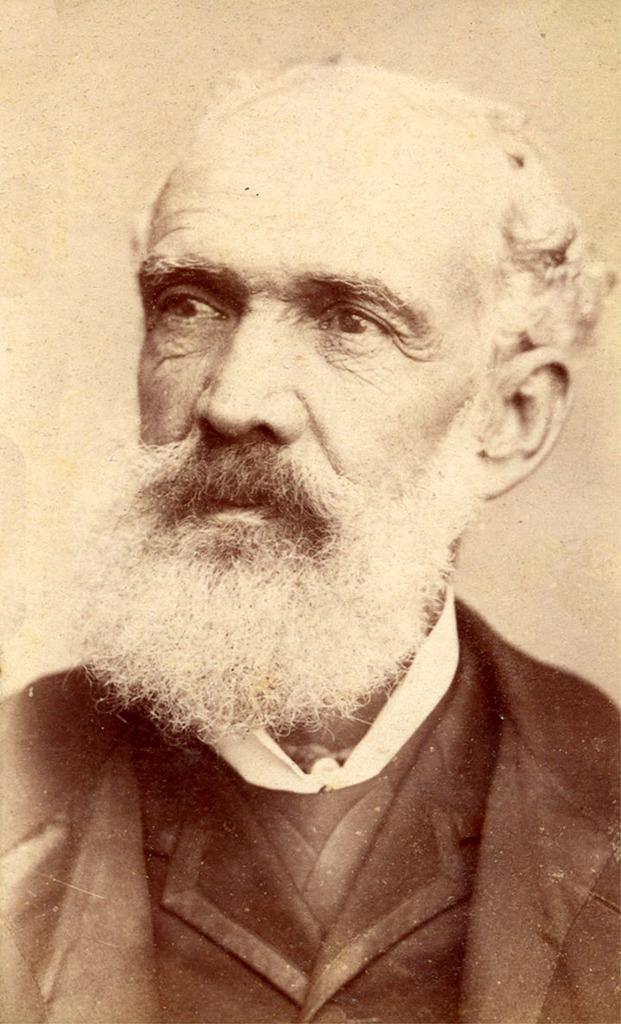Can you describe this image briefly? In this image we can see a photo of a man. 